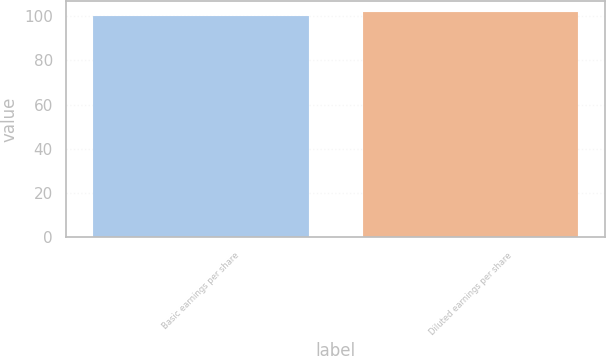Convert chart to OTSL. <chart><loc_0><loc_0><loc_500><loc_500><bar_chart><fcel>Basic earnings per share<fcel>Diluted earnings per share<nl><fcel>100<fcel>101.8<nl></chart> 